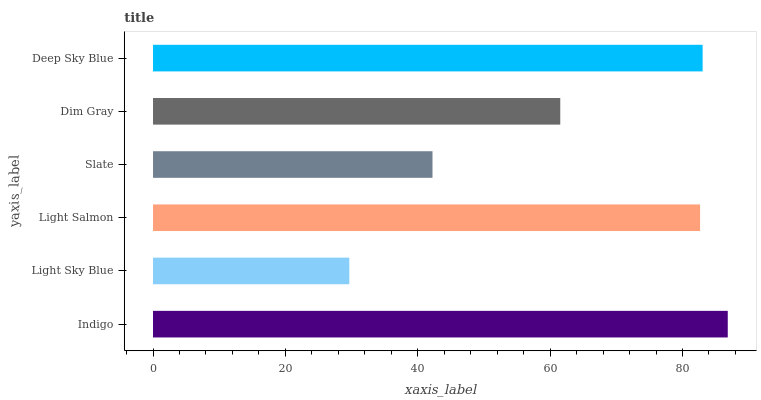Is Light Sky Blue the minimum?
Answer yes or no. Yes. Is Indigo the maximum?
Answer yes or no. Yes. Is Light Salmon the minimum?
Answer yes or no. No. Is Light Salmon the maximum?
Answer yes or no. No. Is Light Salmon greater than Light Sky Blue?
Answer yes or no. Yes. Is Light Sky Blue less than Light Salmon?
Answer yes or no. Yes. Is Light Sky Blue greater than Light Salmon?
Answer yes or no. No. Is Light Salmon less than Light Sky Blue?
Answer yes or no. No. Is Light Salmon the high median?
Answer yes or no. Yes. Is Dim Gray the low median?
Answer yes or no. Yes. Is Deep Sky Blue the high median?
Answer yes or no. No. Is Slate the low median?
Answer yes or no. No. 